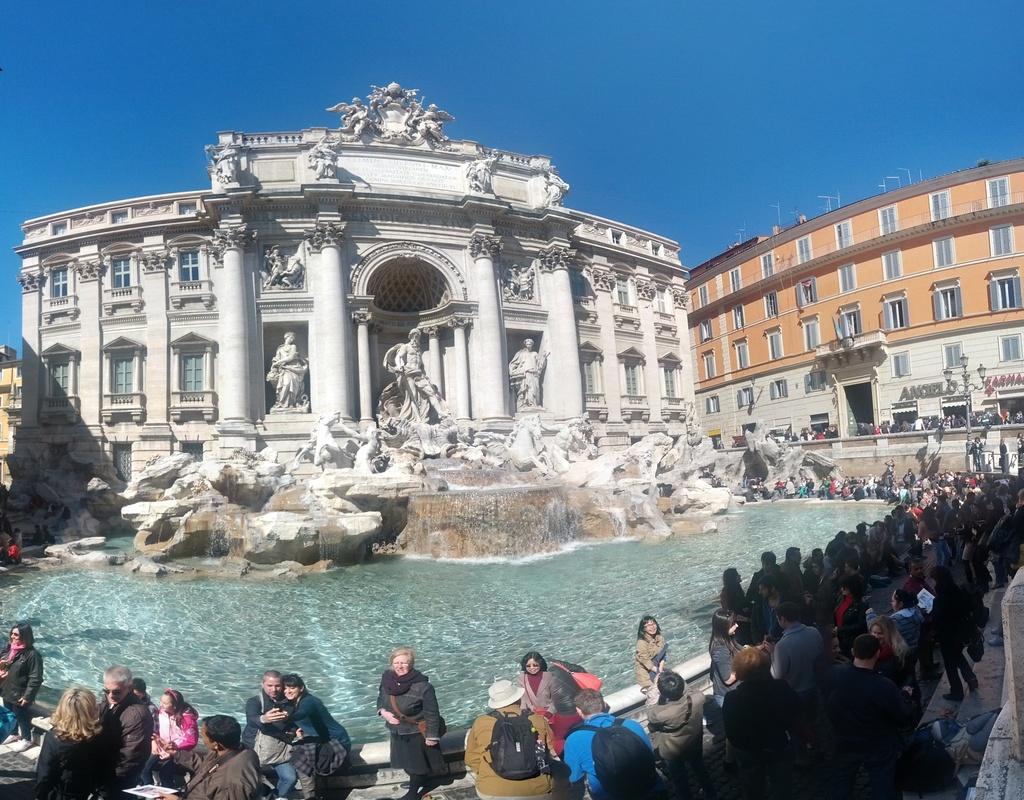How would you summarize this image in a sentence or two? In this image we can see a few buildings and the sculptures, there are some windows, pillars, rocks and the water, also we can see a few people, among them, some people are wearing the bags. 